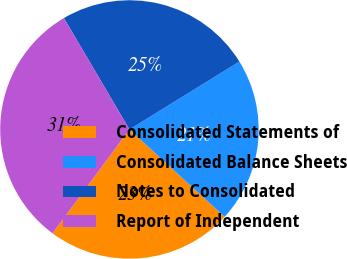Convert chart to OTSL. <chart><loc_0><loc_0><loc_500><loc_500><pie_chart><fcel>Consolidated Statements of<fcel>Consolidated Balance Sheets<fcel>Notes to Consolidated<fcel>Report of Independent<nl><fcel>23.32%<fcel>20.63%<fcel>24.66%<fcel>31.39%<nl></chart> 